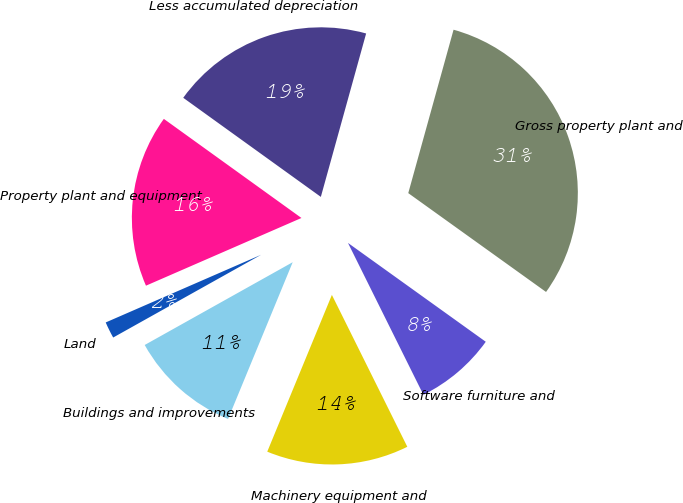Convert chart. <chart><loc_0><loc_0><loc_500><loc_500><pie_chart><fcel>Land<fcel>Buildings and improvements<fcel>Machinery equipment and<fcel>Software furniture and<fcel>Gross property plant and<fcel>Less accumulated depreciation<fcel>Property plant and equipment<nl><fcel>1.58%<fcel>10.66%<fcel>13.56%<fcel>7.76%<fcel>30.6%<fcel>19.37%<fcel>16.47%<nl></chart> 